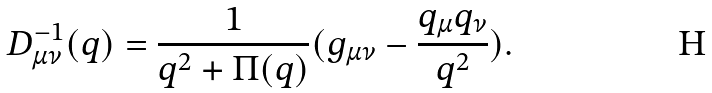Convert formula to latex. <formula><loc_0><loc_0><loc_500><loc_500>D _ { \mu \nu } ^ { - 1 } ( q ) = \frac { 1 } { q ^ { 2 } + \Pi ( q ) } ( g _ { \mu \nu } - \frac { q _ { \mu } q _ { \nu } } { q ^ { 2 } } ) .</formula> 